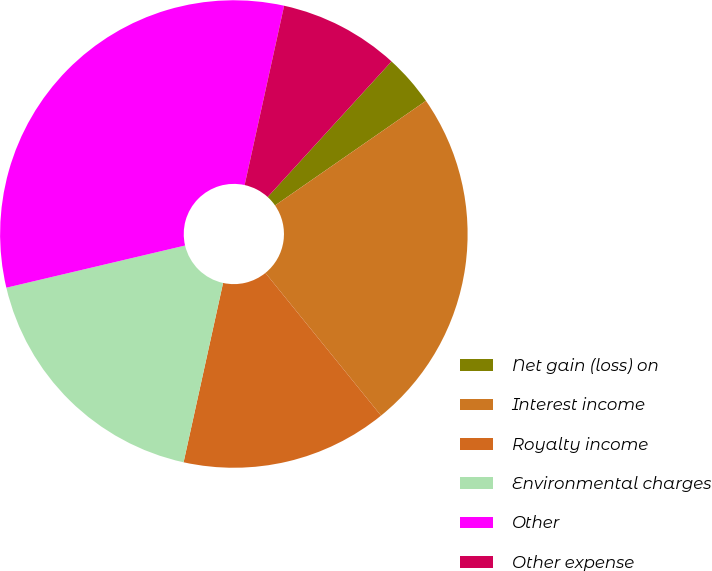Convert chart. <chart><loc_0><loc_0><loc_500><loc_500><pie_chart><fcel>Net gain (loss) on<fcel>Interest income<fcel>Royalty income<fcel>Environmental charges<fcel>Other<fcel>Other expense<nl><fcel>3.57%<fcel>23.81%<fcel>14.29%<fcel>17.86%<fcel>32.14%<fcel>8.33%<nl></chart> 